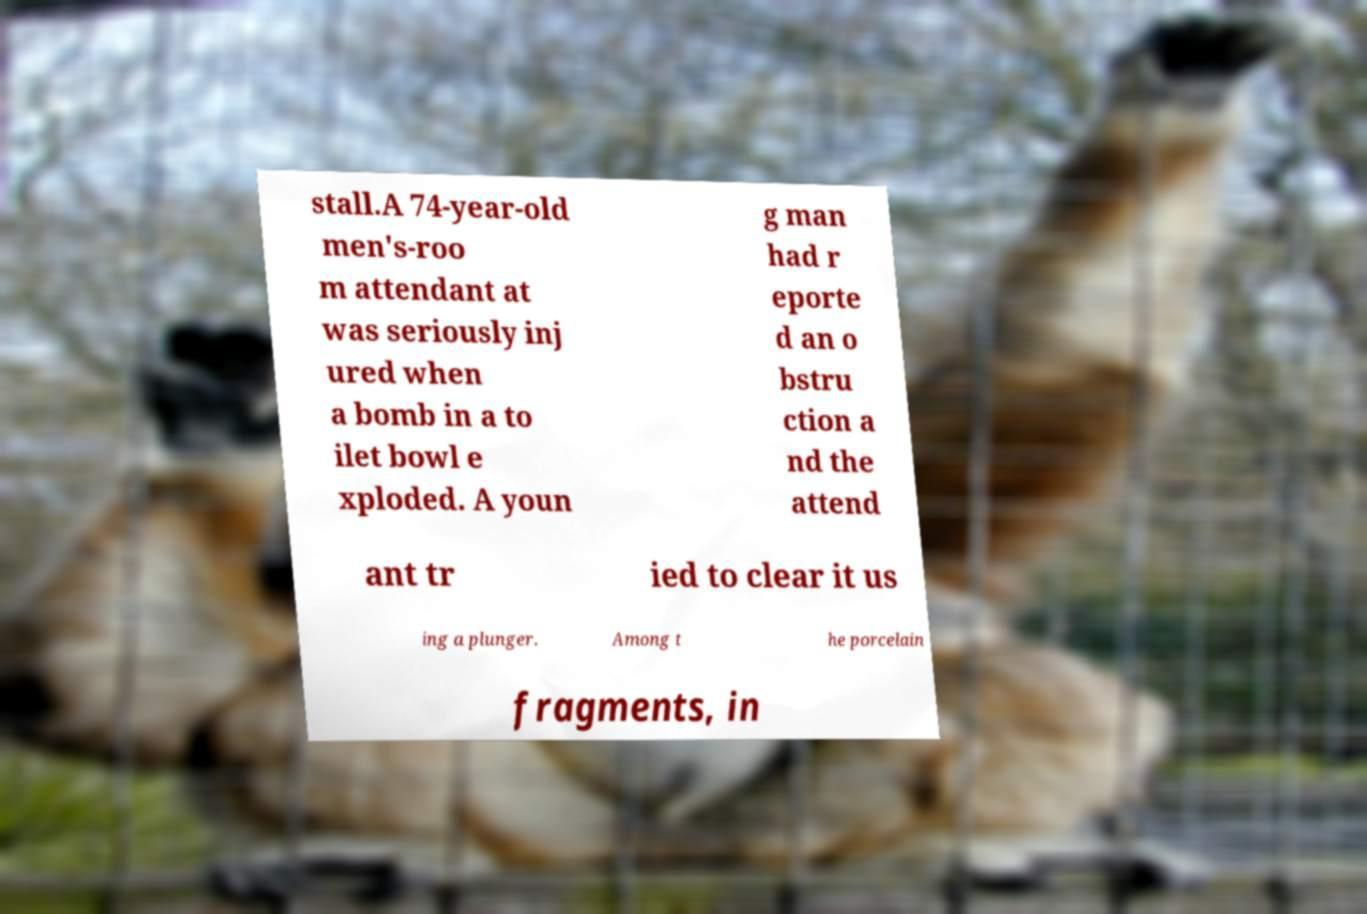Could you assist in decoding the text presented in this image and type it out clearly? stall.A 74-year-old men's-roo m attendant at was seriously inj ured when a bomb in a to ilet bowl e xploded. A youn g man had r eporte d an o bstru ction a nd the attend ant tr ied to clear it us ing a plunger. Among t he porcelain fragments, in 